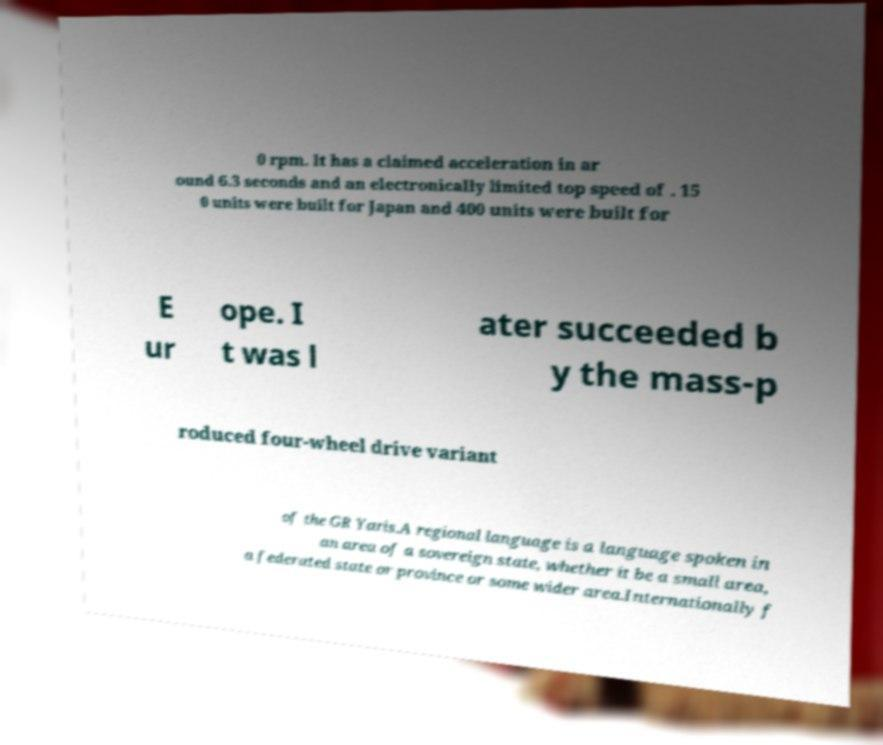Can you read and provide the text displayed in the image?This photo seems to have some interesting text. Can you extract and type it out for me? 0 rpm. It has a claimed acceleration in ar ound 6.3 seconds and an electronically limited top speed of . 15 0 units were built for Japan and 400 units were built for E ur ope. I t was l ater succeeded b y the mass-p roduced four-wheel drive variant of the GR Yaris.A regional language is a language spoken in an area of a sovereign state, whether it be a small area, a federated state or province or some wider area.Internationally f 